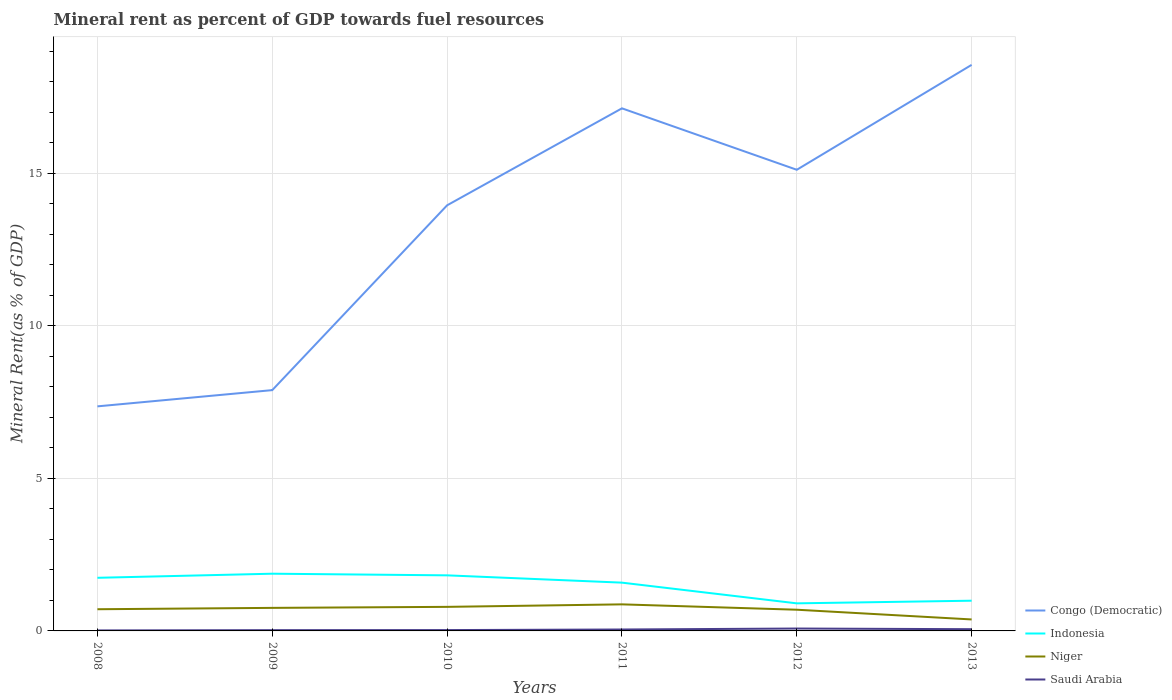How many different coloured lines are there?
Provide a short and direct response. 4. Across all years, what is the maximum mineral rent in Indonesia?
Offer a terse response. 0.9. In which year was the mineral rent in Niger maximum?
Your answer should be compact. 2013. What is the total mineral rent in Saudi Arabia in the graph?
Offer a very short reply. -0.01. What is the difference between the highest and the second highest mineral rent in Indonesia?
Provide a short and direct response. 0.97. How many lines are there?
Your response must be concise. 4. How many years are there in the graph?
Ensure brevity in your answer.  6. Are the values on the major ticks of Y-axis written in scientific E-notation?
Offer a very short reply. No. Does the graph contain grids?
Ensure brevity in your answer.  Yes. Where does the legend appear in the graph?
Provide a succinct answer. Bottom right. What is the title of the graph?
Give a very brief answer. Mineral rent as percent of GDP towards fuel resources. Does "Dominica" appear as one of the legend labels in the graph?
Make the answer very short. No. What is the label or title of the Y-axis?
Give a very brief answer. Mineral Rent(as % of GDP). What is the Mineral Rent(as % of GDP) in Congo (Democratic) in 2008?
Offer a terse response. 7.36. What is the Mineral Rent(as % of GDP) of Indonesia in 2008?
Your answer should be compact. 1.74. What is the Mineral Rent(as % of GDP) in Niger in 2008?
Your answer should be compact. 0.71. What is the Mineral Rent(as % of GDP) in Saudi Arabia in 2008?
Your response must be concise. 0.02. What is the Mineral Rent(as % of GDP) in Congo (Democratic) in 2009?
Ensure brevity in your answer.  7.89. What is the Mineral Rent(as % of GDP) of Indonesia in 2009?
Make the answer very short. 1.87. What is the Mineral Rent(as % of GDP) of Niger in 2009?
Give a very brief answer. 0.76. What is the Mineral Rent(as % of GDP) of Saudi Arabia in 2009?
Give a very brief answer. 0.03. What is the Mineral Rent(as % of GDP) in Congo (Democratic) in 2010?
Offer a very short reply. 13.95. What is the Mineral Rent(as % of GDP) in Indonesia in 2010?
Keep it short and to the point. 1.82. What is the Mineral Rent(as % of GDP) in Niger in 2010?
Your answer should be compact. 0.79. What is the Mineral Rent(as % of GDP) in Saudi Arabia in 2010?
Give a very brief answer. 0.03. What is the Mineral Rent(as % of GDP) in Congo (Democratic) in 2011?
Provide a short and direct response. 17.13. What is the Mineral Rent(as % of GDP) in Indonesia in 2011?
Make the answer very short. 1.58. What is the Mineral Rent(as % of GDP) in Niger in 2011?
Provide a succinct answer. 0.87. What is the Mineral Rent(as % of GDP) of Saudi Arabia in 2011?
Offer a terse response. 0.05. What is the Mineral Rent(as % of GDP) in Congo (Democratic) in 2012?
Offer a terse response. 15.11. What is the Mineral Rent(as % of GDP) of Indonesia in 2012?
Give a very brief answer. 0.9. What is the Mineral Rent(as % of GDP) in Niger in 2012?
Provide a succinct answer. 0.69. What is the Mineral Rent(as % of GDP) in Saudi Arabia in 2012?
Your answer should be very brief. 0.08. What is the Mineral Rent(as % of GDP) in Congo (Democratic) in 2013?
Ensure brevity in your answer.  18.55. What is the Mineral Rent(as % of GDP) in Indonesia in 2013?
Offer a very short reply. 0.99. What is the Mineral Rent(as % of GDP) in Niger in 2013?
Provide a short and direct response. 0.38. What is the Mineral Rent(as % of GDP) in Saudi Arabia in 2013?
Provide a short and direct response. 0.06. Across all years, what is the maximum Mineral Rent(as % of GDP) of Congo (Democratic)?
Your answer should be compact. 18.55. Across all years, what is the maximum Mineral Rent(as % of GDP) of Indonesia?
Offer a very short reply. 1.87. Across all years, what is the maximum Mineral Rent(as % of GDP) in Niger?
Your answer should be compact. 0.87. Across all years, what is the maximum Mineral Rent(as % of GDP) of Saudi Arabia?
Provide a short and direct response. 0.08. Across all years, what is the minimum Mineral Rent(as % of GDP) in Congo (Democratic)?
Give a very brief answer. 7.36. Across all years, what is the minimum Mineral Rent(as % of GDP) of Indonesia?
Provide a succinct answer. 0.9. Across all years, what is the minimum Mineral Rent(as % of GDP) of Niger?
Offer a very short reply. 0.38. Across all years, what is the minimum Mineral Rent(as % of GDP) in Saudi Arabia?
Your answer should be very brief. 0.02. What is the total Mineral Rent(as % of GDP) in Congo (Democratic) in the graph?
Keep it short and to the point. 79.99. What is the total Mineral Rent(as % of GDP) of Indonesia in the graph?
Give a very brief answer. 8.91. What is the total Mineral Rent(as % of GDP) of Niger in the graph?
Keep it short and to the point. 4.2. What is the total Mineral Rent(as % of GDP) of Saudi Arabia in the graph?
Give a very brief answer. 0.25. What is the difference between the Mineral Rent(as % of GDP) of Congo (Democratic) in 2008 and that in 2009?
Make the answer very short. -0.53. What is the difference between the Mineral Rent(as % of GDP) of Indonesia in 2008 and that in 2009?
Offer a very short reply. -0.13. What is the difference between the Mineral Rent(as % of GDP) in Niger in 2008 and that in 2009?
Your answer should be very brief. -0.04. What is the difference between the Mineral Rent(as % of GDP) in Saudi Arabia in 2008 and that in 2009?
Offer a terse response. -0.01. What is the difference between the Mineral Rent(as % of GDP) in Congo (Democratic) in 2008 and that in 2010?
Ensure brevity in your answer.  -6.59. What is the difference between the Mineral Rent(as % of GDP) in Indonesia in 2008 and that in 2010?
Offer a very short reply. -0.08. What is the difference between the Mineral Rent(as % of GDP) in Niger in 2008 and that in 2010?
Your answer should be very brief. -0.08. What is the difference between the Mineral Rent(as % of GDP) of Saudi Arabia in 2008 and that in 2010?
Keep it short and to the point. -0.01. What is the difference between the Mineral Rent(as % of GDP) in Congo (Democratic) in 2008 and that in 2011?
Keep it short and to the point. -9.77. What is the difference between the Mineral Rent(as % of GDP) of Indonesia in 2008 and that in 2011?
Your answer should be very brief. 0.16. What is the difference between the Mineral Rent(as % of GDP) in Niger in 2008 and that in 2011?
Keep it short and to the point. -0.16. What is the difference between the Mineral Rent(as % of GDP) in Saudi Arabia in 2008 and that in 2011?
Provide a short and direct response. -0.03. What is the difference between the Mineral Rent(as % of GDP) of Congo (Democratic) in 2008 and that in 2012?
Your answer should be compact. -7.75. What is the difference between the Mineral Rent(as % of GDP) in Indonesia in 2008 and that in 2012?
Your answer should be compact. 0.84. What is the difference between the Mineral Rent(as % of GDP) in Niger in 2008 and that in 2012?
Your answer should be compact. 0.02. What is the difference between the Mineral Rent(as % of GDP) of Saudi Arabia in 2008 and that in 2012?
Offer a terse response. -0.06. What is the difference between the Mineral Rent(as % of GDP) of Congo (Democratic) in 2008 and that in 2013?
Your answer should be very brief. -11.19. What is the difference between the Mineral Rent(as % of GDP) of Indonesia in 2008 and that in 2013?
Make the answer very short. 0.75. What is the difference between the Mineral Rent(as % of GDP) of Niger in 2008 and that in 2013?
Provide a succinct answer. 0.33. What is the difference between the Mineral Rent(as % of GDP) of Saudi Arabia in 2008 and that in 2013?
Your answer should be compact. -0.04. What is the difference between the Mineral Rent(as % of GDP) of Congo (Democratic) in 2009 and that in 2010?
Your response must be concise. -6.06. What is the difference between the Mineral Rent(as % of GDP) of Indonesia in 2009 and that in 2010?
Provide a succinct answer. 0.05. What is the difference between the Mineral Rent(as % of GDP) in Niger in 2009 and that in 2010?
Your response must be concise. -0.03. What is the difference between the Mineral Rent(as % of GDP) of Saudi Arabia in 2009 and that in 2010?
Give a very brief answer. -0. What is the difference between the Mineral Rent(as % of GDP) of Congo (Democratic) in 2009 and that in 2011?
Offer a terse response. -9.24. What is the difference between the Mineral Rent(as % of GDP) in Indonesia in 2009 and that in 2011?
Your response must be concise. 0.29. What is the difference between the Mineral Rent(as % of GDP) in Niger in 2009 and that in 2011?
Make the answer very short. -0.11. What is the difference between the Mineral Rent(as % of GDP) in Saudi Arabia in 2009 and that in 2011?
Provide a short and direct response. -0.02. What is the difference between the Mineral Rent(as % of GDP) in Congo (Democratic) in 2009 and that in 2012?
Give a very brief answer. -7.22. What is the difference between the Mineral Rent(as % of GDP) in Indonesia in 2009 and that in 2012?
Your answer should be compact. 0.97. What is the difference between the Mineral Rent(as % of GDP) of Niger in 2009 and that in 2012?
Keep it short and to the point. 0.06. What is the difference between the Mineral Rent(as % of GDP) of Saudi Arabia in 2009 and that in 2012?
Provide a short and direct response. -0.05. What is the difference between the Mineral Rent(as % of GDP) in Congo (Democratic) in 2009 and that in 2013?
Your answer should be compact. -10.66. What is the difference between the Mineral Rent(as % of GDP) of Indonesia in 2009 and that in 2013?
Offer a terse response. 0.88. What is the difference between the Mineral Rent(as % of GDP) of Niger in 2009 and that in 2013?
Offer a very short reply. 0.38. What is the difference between the Mineral Rent(as % of GDP) in Saudi Arabia in 2009 and that in 2013?
Provide a short and direct response. -0.03. What is the difference between the Mineral Rent(as % of GDP) in Congo (Democratic) in 2010 and that in 2011?
Provide a succinct answer. -3.18. What is the difference between the Mineral Rent(as % of GDP) of Indonesia in 2010 and that in 2011?
Ensure brevity in your answer.  0.24. What is the difference between the Mineral Rent(as % of GDP) of Niger in 2010 and that in 2011?
Your response must be concise. -0.08. What is the difference between the Mineral Rent(as % of GDP) in Saudi Arabia in 2010 and that in 2011?
Your answer should be compact. -0.02. What is the difference between the Mineral Rent(as % of GDP) of Congo (Democratic) in 2010 and that in 2012?
Your answer should be very brief. -1.16. What is the difference between the Mineral Rent(as % of GDP) of Indonesia in 2010 and that in 2012?
Offer a terse response. 0.92. What is the difference between the Mineral Rent(as % of GDP) in Niger in 2010 and that in 2012?
Your response must be concise. 0.09. What is the difference between the Mineral Rent(as % of GDP) of Saudi Arabia in 2010 and that in 2012?
Give a very brief answer. -0.05. What is the difference between the Mineral Rent(as % of GDP) of Congo (Democratic) in 2010 and that in 2013?
Make the answer very short. -4.6. What is the difference between the Mineral Rent(as % of GDP) in Indonesia in 2010 and that in 2013?
Your answer should be very brief. 0.83. What is the difference between the Mineral Rent(as % of GDP) in Niger in 2010 and that in 2013?
Ensure brevity in your answer.  0.41. What is the difference between the Mineral Rent(as % of GDP) in Saudi Arabia in 2010 and that in 2013?
Provide a succinct answer. -0.03. What is the difference between the Mineral Rent(as % of GDP) of Congo (Democratic) in 2011 and that in 2012?
Offer a very short reply. 2.01. What is the difference between the Mineral Rent(as % of GDP) in Indonesia in 2011 and that in 2012?
Keep it short and to the point. 0.68. What is the difference between the Mineral Rent(as % of GDP) in Niger in 2011 and that in 2012?
Provide a short and direct response. 0.18. What is the difference between the Mineral Rent(as % of GDP) of Saudi Arabia in 2011 and that in 2012?
Keep it short and to the point. -0.03. What is the difference between the Mineral Rent(as % of GDP) of Congo (Democratic) in 2011 and that in 2013?
Offer a terse response. -1.42. What is the difference between the Mineral Rent(as % of GDP) in Indonesia in 2011 and that in 2013?
Make the answer very short. 0.59. What is the difference between the Mineral Rent(as % of GDP) of Niger in 2011 and that in 2013?
Provide a succinct answer. 0.49. What is the difference between the Mineral Rent(as % of GDP) in Saudi Arabia in 2011 and that in 2013?
Provide a short and direct response. -0.01. What is the difference between the Mineral Rent(as % of GDP) in Congo (Democratic) in 2012 and that in 2013?
Offer a terse response. -3.44. What is the difference between the Mineral Rent(as % of GDP) in Indonesia in 2012 and that in 2013?
Ensure brevity in your answer.  -0.09. What is the difference between the Mineral Rent(as % of GDP) of Niger in 2012 and that in 2013?
Offer a very short reply. 0.32. What is the difference between the Mineral Rent(as % of GDP) in Saudi Arabia in 2012 and that in 2013?
Your response must be concise. 0.02. What is the difference between the Mineral Rent(as % of GDP) of Congo (Democratic) in 2008 and the Mineral Rent(as % of GDP) of Indonesia in 2009?
Give a very brief answer. 5.48. What is the difference between the Mineral Rent(as % of GDP) in Congo (Democratic) in 2008 and the Mineral Rent(as % of GDP) in Niger in 2009?
Keep it short and to the point. 6.6. What is the difference between the Mineral Rent(as % of GDP) in Congo (Democratic) in 2008 and the Mineral Rent(as % of GDP) in Saudi Arabia in 2009?
Keep it short and to the point. 7.33. What is the difference between the Mineral Rent(as % of GDP) in Indonesia in 2008 and the Mineral Rent(as % of GDP) in Niger in 2009?
Offer a terse response. 0.99. What is the difference between the Mineral Rent(as % of GDP) of Indonesia in 2008 and the Mineral Rent(as % of GDP) of Saudi Arabia in 2009?
Keep it short and to the point. 1.72. What is the difference between the Mineral Rent(as % of GDP) in Niger in 2008 and the Mineral Rent(as % of GDP) in Saudi Arabia in 2009?
Keep it short and to the point. 0.69. What is the difference between the Mineral Rent(as % of GDP) of Congo (Democratic) in 2008 and the Mineral Rent(as % of GDP) of Indonesia in 2010?
Make the answer very short. 5.54. What is the difference between the Mineral Rent(as % of GDP) of Congo (Democratic) in 2008 and the Mineral Rent(as % of GDP) of Niger in 2010?
Your answer should be very brief. 6.57. What is the difference between the Mineral Rent(as % of GDP) of Congo (Democratic) in 2008 and the Mineral Rent(as % of GDP) of Saudi Arabia in 2010?
Your answer should be compact. 7.33. What is the difference between the Mineral Rent(as % of GDP) in Indonesia in 2008 and the Mineral Rent(as % of GDP) in Niger in 2010?
Provide a succinct answer. 0.95. What is the difference between the Mineral Rent(as % of GDP) in Indonesia in 2008 and the Mineral Rent(as % of GDP) in Saudi Arabia in 2010?
Your response must be concise. 1.71. What is the difference between the Mineral Rent(as % of GDP) of Niger in 2008 and the Mineral Rent(as % of GDP) of Saudi Arabia in 2010?
Give a very brief answer. 0.68. What is the difference between the Mineral Rent(as % of GDP) of Congo (Democratic) in 2008 and the Mineral Rent(as % of GDP) of Indonesia in 2011?
Your response must be concise. 5.78. What is the difference between the Mineral Rent(as % of GDP) of Congo (Democratic) in 2008 and the Mineral Rent(as % of GDP) of Niger in 2011?
Provide a short and direct response. 6.49. What is the difference between the Mineral Rent(as % of GDP) of Congo (Democratic) in 2008 and the Mineral Rent(as % of GDP) of Saudi Arabia in 2011?
Offer a terse response. 7.31. What is the difference between the Mineral Rent(as % of GDP) of Indonesia in 2008 and the Mineral Rent(as % of GDP) of Niger in 2011?
Give a very brief answer. 0.87. What is the difference between the Mineral Rent(as % of GDP) of Indonesia in 2008 and the Mineral Rent(as % of GDP) of Saudi Arabia in 2011?
Keep it short and to the point. 1.69. What is the difference between the Mineral Rent(as % of GDP) in Niger in 2008 and the Mineral Rent(as % of GDP) in Saudi Arabia in 2011?
Provide a succinct answer. 0.66. What is the difference between the Mineral Rent(as % of GDP) in Congo (Democratic) in 2008 and the Mineral Rent(as % of GDP) in Indonesia in 2012?
Ensure brevity in your answer.  6.46. What is the difference between the Mineral Rent(as % of GDP) of Congo (Democratic) in 2008 and the Mineral Rent(as % of GDP) of Niger in 2012?
Your answer should be compact. 6.66. What is the difference between the Mineral Rent(as % of GDP) in Congo (Democratic) in 2008 and the Mineral Rent(as % of GDP) in Saudi Arabia in 2012?
Provide a short and direct response. 7.28. What is the difference between the Mineral Rent(as % of GDP) in Indonesia in 2008 and the Mineral Rent(as % of GDP) in Niger in 2012?
Your answer should be compact. 1.05. What is the difference between the Mineral Rent(as % of GDP) of Indonesia in 2008 and the Mineral Rent(as % of GDP) of Saudi Arabia in 2012?
Ensure brevity in your answer.  1.66. What is the difference between the Mineral Rent(as % of GDP) in Niger in 2008 and the Mineral Rent(as % of GDP) in Saudi Arabia in 2012?
Your answer should be compact. 0.63. What is the difference between the Mineral Rent(as % of GDP) of Congo (Democratic) in 2008 and the Mineral Rent(as % of GDP) of Indonesia in 2013?
Ensure brevity in your answer.  6.37. What is the difference between the Mineral Rent(as % of GDP) of Congo (Democratic) in 2008 and the Mineral Rent(as % of GDP) of Niger in 2013?
Make the answer very short. 6.98. What is the difference between the Mineral Rent(as % of GDP) of Congo (Democratic) in 2008 and the Mineral Rent(as % of GDP) of Saudi Arabia in 2013?
Make the answer very short. 7.3. What is the difference between the Mineral Rent(as % of GDP) in Indonesia in 2008 and the Mineral Rent(as % of GDP) in Niger in 2013?
Ensure brevity in your answer.  1.36. What is the difference between the Mineral Rent(as % of GDP) of Indonesia in 2008 and the Mineral Rent(as % of GDP) of Saudi Arabia in 2013?
Your answer should be compact. 1.68. What is the difference between the Mineral Rent(as % of GDP) in Niger in 2008 and the Mineral Rent(as % of GDP) in Saudi Arabia in 2013?
Your answer should be compact. 0.65. What is the difference between the Mineral Rent(as % of GDP) in Congo (Democratic) in 2009 and the Mineral Rent(as % of GDP) in Indonesia in 2010?
Make the answer very short. 6.07. What is the difference between the Mineral Rent(as % of GDP) in Congo (Democratic) in 2009 and the Mineral Rent(as % of GDP) in Niger in 2010?
Offer a very short reply. 7.1. What is the difference between the Mineral Rent(as % of GDP) of Congo (Democratic) in 2009 and the Mineral Rent(as % of GDP) of Saudi Arabia in 2010?
Make the answer very short. 7.86. What is the difference between the Mineral Rent(as % of GDP) of Indonesia in 2009 and the Mineral Rent(as % of GDP) of Niger in 2010?
Provide a short and direct response. 1.09. What is the difference between the Mineral Rent(as % of GDP) of Indonesia in 2009 and the Mineral Rent(as % of GDP) of Saudi Arabia in 2010?
Keep it short and to the point. 1.85. What is the difference between the Mineral Rent(as % of GDP) of Niger in 2009 and the Mineral Rent(as % of GDP) of Saudi Arabia in 2010?
Give a very brief answer. 0.73. What is the difference between the Mineral Rent(as % of GDP) in Congo (Democratic) in 2009 and the Mineral Rent(as % of GDP) in Indonesia in 2011?
Offer a terse response. 6.31. What is the difference between the Mineral Rent(as % of GDP) in Congo (Democratic) in 2009 and the Mineral Rent(as % of GDP) in Niger in 2011?
Provide a short and direct response. 7.02. What is the difference between the Mineral Rent(as % of GDP) of Congo (Democratic) in 2009 and the Mineral Rent(as % of GDP) of Saudi Arabia in 2011?
Provide a succinct answer. 7.85. What is the difference between the Mineral Rent(as % of GDP) of Indonesia in 2009 and the Mineral Rent(as % of GDP) of Niger in 2011?
Give a very brief answer. 1. What is the difference between the Mineral Rent(as % of GDP) of Indonesia in 2009 and the Mineral Rent(as % of GDP) of Saudi Arabia in 2011?
Provide a short and direct response. 1.83. What is the difference between the Mineral Rent(as % of GDP) in Niger in 2009 and the Mineral Rent(as % of GDP) in Saudi Arabia in 2011?
Your answer should be compact. 0.71. What is the difference between the Mineral Rent(as % of GDP) in Congo (Democratic) in 2009 and the Mineral Rent(as % of GDP) in Indonesia in 2012?
Your answer should be compact. 6.99. What is the difference between the Mineral Rent(as % of GDP) in Congo (Democratic) in 2009 and the Mineral Rent(as % of GDP) in Niger in 2012?
Offer a terse response. 7.2. What is the difference between the Mineral Rent(as % of GDP) in Congo (Democratic) in 2009 and the Mineral Rent(as % of GDP) in Saudi Arabia in 2012?
Offer a terse response. 7.81. What is the difference between the Mineral Rent(as % of GDP) of Indonesia in 2009 and the Mineral Rent(as % of GDP) of Niger in 2012?
Your response must be concise. 1.18. What is the difference between the Mineral Rent(as % of GDP) of Indonesia in 2009 and the Mineral Rent(as % of GDP) of Saudi Arabia in 2012?
Your response must be concise. 1.8. What is the difference between the Mineral Rent(as % of GDP) of Niger in 2009 and the Mineral Rent(as % of GDP) of Saudi Arabia in 2012?
Your answer should be very brief. 0.68. What is the difference between the Mineral Rent(as % of GDP) of Congo (Democratic) in 2009 and the Mineral Rent(as % of GDP) of Indonesia in 2013?
Provide a succinct answer. 6.9. What is the difference between the Mineral Rent(as % of GDP) in Congo (Democratic) in 2009 and the Mineral Rent(as % of GDP) in Niger in 2013?
Give a very brief answer. 7.52. What is the difference between the Mineral Rent(as % of GDP) in Congo (Democratic) in 2009 and the Mineral Rent(as % of GDP) in Saudi Arabia in 2013?
Provide a short and direct response. 7.83. What is the difference between the Mineral Rent(as % of GDP) of Indonesia in 2009 and the Mineral Rent(as % of GDP) of Niger in 2013?
Provide a short and direct response. 1.5. What is the difference between the Mineral Rent(as % of GDP) of Indonesia in 2009 and the Mineral Rent(as % of GDP) of Saudi Arabia in 2013?
Your response must be concise. 1.82. What is the difference between the Mineral Rent(as % of GDP) of Niger in 2009 and the Mineral Rent(as % of GDP) of Saudi Arabia in 2013?
Your response must be concise. 0.7. What is the difference between the Mineral Rent(as % of GDP) of Congo (Democratic) in 2010 and the Mineral Rent(as % of GDP) of Indonesia in 2011?
Your answer should be very brief. 12.37. What is the difference between the Mineral Rent(as % of GDP) in Congo (Democratic) in 2010 and the Mineral Rent(as % of GDP) in Niger in 2011?
Provide a short and direct response. 13.08. What is the difference between the Mineral Rent(as % of GDP) of Congo (Democratic) in 2010 and the Mineral Rent(as % of GDP) of Saudi Arabia in 2011?
Give a very brief answer. 13.9. What is the difference between the Mineral Rent(as % of GDP) of Indonesia in 2010 and the Mineral Rent(as % of GDP) of Niger in 2011?
Provide a short and direct response. 0.95. What is the difference between the Mineral Rent(as % of GDP) of Indonesia in 2010 and the Mineral Rent(as % of GDP) of Saudi Arabia in 2011?
Provide a short and direct response. 1.77. What is the difference between the Mineral Rent(as % of GDP) of Niger in 2010 and the Mineral Rent(as % of GDP) of Saudi Arabia in 2011?
Ensure brevity in your answer.  0.74. What is the difference between the Mineral Rent(as % of GDP) in Congo (Democratic) in 2010 and the Mineral Rent(as % of GDP) in Indonesia in 2012?
Your answer should be very brief. 13.04. What is the difference between the Mineral Rent(as % of GDP) in Congo (Democratic) in 2010 and the Mineral Rent(as % of GDP) in Niger in 2012?
Your answer should be very brief. 13.25. What is the difference between the Mineral Rent(as % of GDP) of Congo (Democratic) in 2010 and the Mineral Rent(as % of GDP) of Saudi Arabia in 2012?
Provide a succinct answer. 13.87. What is the difference between the Mineral Rent(as % of GDP) in Indonesia in 2010 and the Mineral Rent(as % of GDP) in Niger in 2012?
Offer a very short reply. 1.13. What is the difference between the Mineral Rent(as % of GDP) in Indonesia in 2010 and the Mineral Rent(as % of GDP) in Saudi Arabia in 2012?
Offer a terse response. 1.74. What is the difference between the Mineral Rent(as % of GDP) of Niger in 2010 and the Mineral Rent(as % of GDP) of Saudi Arabia in 2012?
Your answer should be very brief. 0.71. What is the difference between the Mineral Rent(as % of GDP) in Congo (Democratic) in 2010 and the Mineral Rent(as % of GDP) in Indonesia in 2013?
Keep it short and to the point. 12.96. What is the difference between the Mineral Rent(as % of GDP) in Congo (Democratic) in 2010 and the Mineral Rent(as % of GDP) in Niger in 2013?
Offer a very short reply. 13.57. What is the difference between the Mineral Rent(as % of GDP) in Congo (Democratic) in 2010 and the Mineral Rent(as % of GDP) in Saudi Arabia in 2013?
Provide a short and direct response. 13.89. What is the difference between the Mineral Rent(as % of GDP) in Indonesia in 2010 and the Mineral Rent(as % of GDP) in Niger in 2013?
Keep it short and to the point. 1.45. What is the difference between the Mineral Rent(as % of GDP) of Indonesia in 2010 and the Mineral Rent(as % of GDP) of Saudi Arabia in 2013?
Give a very brief answer. 1.76. What is the difference between the Mineral Rent(as % of GDP) in Niger in 2010 and the Mineral Rent(as % of GDP) in Saudi Arabia in 2013?
Offer a very short reply. 0.73. What is the difference between the Mineral Rent(as % of GDP) in Congo (Democratic) in 2011 and the Mineral Rent(as % of GDP) in Indonesia in 2012?
Offer a terse response. 16.22. What is the difference between the Mineral Rent(as % of GDP) of Congo (Democratic) in 2011 and the Mineral Rent(as % of GDP) of Niger in 2012?
Keep it short and to the point. 16.43. What is the difference between the Mineral Rent(as % of GDP) of Congo (Democratic) in 2011 and the Mineral Rent(as % of GDP) of Saudi Arabia in 2012?
Offer a terse response. 17.05. What is the difference between the Mineral Rent(as % of GDP) in Indonesia in 2011 and the Mineral Rent(as % of GDP) in Niger in 2012?
Offer a very short reply. 0.89. What is the difference between the Mineral Rent(as % of GDP) in Indonesia in 2011 and the Mineral Rent(as % of GDP) in Saudi Arabia in 2012?
Provide a succinct answer. 1.5. What is the difference between the Mineral Rent(as % of GDP) in Niger in 2011 and the Mineral Rent(as % of GDP) in Saudi Arabia in 2012?
Offer a very short reply. 0.79. What is the difference between the Mineral Rent(as % of GDP) of Congo (Democratic) in 2011 and the Mineral Rent(as % of GDP) of Indonesia in 2013?
Your answer should be compact. 16.14. What is the difference between the Mineral Rent(as % of GDP) of Congo (Democratic) in 2011 and the Mineral Rent(as % of GDP) of Niger in 2013?
Your response must be concise. 16.75. What is the difference between the Mineral Rent(as % of GDP) of Congo (Democratic) in 2011 and the Mineral Rent(as % of GDP) of Saudi Arabia in 2013?
Provide a succinct answer. 17.07. What is the difference between the Mineral Rent(as % of GDP) of Indonesia in 2011 and the Mineral Rent(as % of GDP) of Niger in 2013?
Provide a succinct answer. 1.21. What is the difference between the Mineral Rent(as % of GDP) in Indonesia in 2011 and the Mineral Rent(as % of GDP) in Saudi Arabia in 2013?
Make the answer very short. 1.53. What is the difference between the Mineral Rent(as % of GDP) in Niger in 2011 and the Mineral Rent(as % of GDP) in Saudi Arabia in 2013?
Give a very brief answer. 0.81. What is the difference between the Mineral Rent(as % of GDP) in Congo (Democratic) in 2012 and the Mineral Rent(as % of GDP) in Indonesia in 2013?
Keep it short and to the point. 14.12. What is the difference between the Mineral Rent(as % of GDP) of Congo (Democratic) in 2012 and the Mineral Rent(as % of GDP) of Niger in 2013?
Your response must be concise. 14.74. What is the difference between the Mineral Rent(as % of GDP) in Congo (Democratic) in 2012 and the Mineral Rent(as % of GDP) in Saudi Arabia in 2013?
Your answer should be compact. 15.06. What is the difference between the Mineral Rent(as % of GDP) in Indonesia in 2012 and the Mineral Rent(as % of GDP) in Niger in 2013?
Offer a terse response. 0.53. What is the difference between the Mineral Rent(as % of GDP) in Indonesia in 2012 and the Mineral Rent(as % of GDP) in Saudi Arabia in 2013?
Give a very brief answer. 0.85. What is the difference between the Mineral Rent(as % of GDP) in Niger in 2012 and the Mineral Rent(as % of GDP) in Saudi Arabia in 2013?
Offer a terse response. 0.64. What is the average Mineral Rent(as % of GDP) in Congo (Democratic) per year?
Provide a succinct answer. 13.33. What is the average Mineral Rent(as % of GDP) in Indonesia per year?
Make the answer very short. 1.49. What is the average Mineral Rent(as % of GDP) of Niger per year?
Make the answer very short. 0.7. What is the average Mineral Rent(as % of GDP) of Saudi Arabia per year?
Give a very brief answer. 0.04. In the year 2008, what is the difference between the Mineral Rent(as % of GDP) in Congo (Democratic) and Mineral Rent(as % of GDP) in Indonesia?
Provide a short and direct response. 5.62. In the year 2008, what is the difference between the Mineral Rent(as % of GDP) in Congo (Democratic) and Mineral Rent(as % of GDP) in Niger?
Your answer should be very brief. 6.65. In the year 2008, what is the difference between the Mineral Rent(as % of GDP) in Congo (Democratic) and Mineral Rent(as % of GDP) in Saudi Arabia?
Give a very brief answer. 7.34. In the year 2008, what is the difference between the Mineral Rent(as % of GDP) in Indonesia and Mineral Rent(as % of GDP) in Niger?
Your answer should be compact. 1.03. In the year 2008, what is the difference between the Mineral Rent(as % of GDP) of Indonesia and Mineral Rent(as % of GDP) of Saudi Arabia?
Your answer should be compact. 1.72. In the year 2008, what is the difference between the Mineral Rent(as % of GDP) of Niger and Mineral Rent(as % of GDP) of Saudi Arabia?
Provide a short and direct response. 0.69. In the year 2009, what is the difference between the Mineral Rent(as % of GDP) of Congo (Democratic) and Mineral Rent(as % of GDP) of Indonesia?
Keep it short and to the point. 6.02. In the year 2009, what is the difference between the Mineral Rent(as % of GDP) of Congo (Democratic) and Mineral Rent(as % of GDP) of Niger?
Offer a terse response. 7.14. In the year 2009, what is the difference between the Mineral Rent(as % of GDP) in Congo (Democratic) and Mineral Rent(as % of GDP) in Saudi Arabia?
Your answer should be very brief. 7.87. In the year 2009, what is the difference between the Mineral Rent(as % of GDP) in Indonesia and Mineral Rent(as % of GDP) in Niger?
Provide a succinct answer. 1.12. In the year 2009, what is the difference between the Mineral Rent(as % of GDP) of Indonesia and Mineral Rent(as % of GDP) of Saudi Arabia?
Offer a very short reply. 1.85. In the year 2009, what is the difference between the Mineral Rent(as % of GDP) in Niger and Mineral Rent(as % of GDP) in Saudi Arabia?
Provide a succinct answer. 0.73. In the year 2010, what is the difference between the Mineral Rent(as % of GDP) in Congo (Democratic) and Mineral Rent(as % of GDP) in Indonesia?
Give a very brief answer. 12.13. In the year 2010, what is the difference between the Mineral Rent(as % of GDP) in Congo (Democratic) and Mineral Rent(as % of GDP) in Niger?
Ensure brevity in your answer.  13.16. In the year 2010, what is the difference between the Mineral Rent(as % of GDP) in Congo (Democratic) and Mineral Rent(as % of GDP) in Saudi Arabia?
Make the answer very short. 13.92. In the year 2010, what is the difference between the Mineral Rent(as % of GDP) in Indonesia and Mineral Rent(as % of GDP) in Niger?
Keep it short and to the point. 1.03. In the year 2010, what is the difference between the Mineral Rent(as % of GDP) in Indonesia and Mineral Rent(as % of GDP) in Saudi Arabia?
Ensure brevity in your answer.  1.79. In the year 2010, what is the difference between the Mineral Rent(as % of GDP) in Niger and Mineral Rent(as % of GDP) in Saudi Arabia?
Ensure brevity in your answer.  0.76. In the year 2011, what is the difference between the Mineral Rent(as % of GDP) in Congo (Democratic) and Mineral Rent(as % of GDP) in Indonesia?
Provide a short and direct response. 15.54. In the year 2011, what is the difference between the Mineral Rent(as % of GDP) of Congo (Democratic) and Mineral Rent(as % of GDP) of Niger?
Keep it short and to the point. 16.26. In the year 2011, what is the difference between the Mineral Rent(as % of GDP) of Congo (Democratic) and Mineral Rent(as % of GDP) of Saudi Arabia?
Ensure brevity in your answer.  17.08. In the year 2011, what is the difference between the Mineral Rent(as % of GDP) of Indonesia and Mineral Rent(as % of GDP) of Niger?
Your response must be concise. 0.71. In the year 2011, what is the difference between the Mineral Rent(as % of GDP) in Indonesia and Mineral Rent(as % of GDP) in Saudi Arabia?
Offer a terse response. 1.54. In the year 2011, what is the difference between the Mineral Rent(as % of GDP) in Niger and Mineral Rent(as % of GDP) in Saudi Arabia?
Offer a very short reply. 0.82. In the year 2012, what is the difference between the Mineral Rent(as % of GDP) in Congo (Democratic) and Mineral Rent(as % of GDP) in Indonesia?
Your answer should be compact. 14.21. In the year 2012, what is the difference between the Mineral Rent(as % of GDP) of Congo (Democratic) and Mineral Rent(as % of GDP) of Niger?
Offer a very short reply. 14.42. In the year 2012, what is the difference between the Mineral Rent(as % of GDP) of Congo (Democratic) and Mineral Rent(as % of GDP) of Saudi Arabia?
Ensure brevity in your answer.  15.03. In the year 2012, what is the difference between the Mineral Rent(as % of GDP) in Indonesia and Mineral Rent(as % of GDP) in Niger?
Keep it short and to the point. 0.21. In the year 2012, what is the difference between the Mineral Rent(as % of GDP) in Indonesia and Mineral Rent(as % of GDP) in Saudi Arabia?
Provide a succinct answer. 0.83. In the year 2012, what is the difference between the Mineral Rent(as % of GDP) of Niger and Mineral Rent(as % of GDP) of Saudi Arabia?
Keep it short and to the point. 0.62. In the year 2013, what is the difference between the Mineral Rent(as % of GDP) in Congo (Democratic) and Mineral Rent(as % of GDP) in Indonesia?
Make the answer very short. 17.56. In the year 2013, what is the difference between the Mineral Rent(as % of GDP) of Congo (Democratic) and Mineral Rent(as % of GDP) of Niger?
Your answer should be compact. 18.18. In the year 2013, what is the difference between the Mineral Rent(as % of GDP) in Congo (Democratic) and Mineral Rent(as % of GDP) in Saudi Arabia?
Offer a terse response. 18.49. In the year 2013, what is the difference between the Mineral Rent(as % of GDP) of Indonesia and Mineral Rent(as % of GDP) of Niger?
Make the answer very short. 0.61. In the year 2013, what is the difference between the Mineral Rent(as % of GDP) of Indonesia and Mineral Rent(as % of GDP) of Saudi Arabia?
Ensure brevity in your answer.  0.93. In the year 2013, what is the difference between the Mineral Rent(as % of GDP) of Niger and Mineral Rent(as % of GDP) of Saudi Arabia?
Offer a very short reply. 0.32. What is the ratio of the Mineral Rent(as % of GDP) of Congo (Democratic) in 2008 to that in 2009?
Ensure brevity in your answer.  0.93. What is the ratio of the Mineral Rent(as % of GDP) in Indonesia in 2008 to that in 2009?
Give a very brief answer. 0.93. What is the ratio of the Mineral Rent(as % of GDP) of Niger in 2008 to that in 2009?
Ensure brevity in your answer.  0.94. What is the ratio of the Mineral Rent(as % of GDP) of Saudi Arabia in 2008 to that in 2009?
Give a very brief answer. 0.65. What is the ratio of the Mineral Rent(as % of GDP) in Congo (Democratic) in 2008 to that in 2010?
Offer a very short reply. 0.53. What is the ratio of the Mineral Rent(as % of GDP) of Indonesia in 2008 to that in 2010?
Provide a short and direct response. 0.96. What is the ratio of the Mineral Rent(as % of GDP) in Niger in 2008 to that in 2010?
Provide a short and direct response. 0.9. What is the ratio of the Mineral Rent(as % of GDP) of Saudi Arabia in 2008 to that in 2010?
Your answer should be very brief. 0.59. What is the ratio of the Mineral Rent(as % of GDP) in Congo (Democratic) in 2008 to that in 2011?
Give a very brief answer. 0.43. What is the ratio of the Mineral Rent(as % of GDP) of Indonesia in 2008 to that in 2011?
Provide a short and direct response. 1.1. What is the ratio of the Mineral Rent(as % of GDP) of Niger in 2008 to that in 2011?
Provide a short and direct response. 0.82. What is the ratio of the Mineral Rent(as % of GDP) in Saudi Arabia in 2008 to that in 2011?
Make the answer very short. 0.35. What is the ratio of the Mineral Rent(as % of GDP) in Congo (Democratic) in 2008 to that in 2012?
Offer a terse response. 0.49. What is the ratio of the Mineral Rent(as % of GDP) in Indonesia in 2008 to that in 2012?
Offer a terse response. 1.93. What is the ratio of the Mineral Rent(as % of GDP) in Niger in 2008 to that in 2012?
Provide a short and direct response. 1.02. What is the ratio of the Mineral Rent(as % of GDP) in Saudi Arabia in 2008 to that in 2012?
Provide a short and direct response. 0.21. What is the ratio of the Mineral Rent(as % of GDP) in Congo (Democratic) in 2008 to that in 2013?
Provide a short and direct response. 0.4. What is the ratio of the Mineral Rent(as % of GDP) in Indonesia in 2008 to that in 2013?
Provide a short and direct response. 1.76. What is the ratio of the Mineral Rent(as % of GDP) in Niger in 2008 to that in 2013?
Give a very brief answer. 1.89. What is the ratio of the Mineral Rent(as % of GDP) in Saudi Arabia in 2008 to that in 2013?
Offer a terse response. 0.29. What is the ratio of the Mineral Rent(as % of GDP) of Congo (Democratic) in 2009 to that in 2010?
Your answer should be very brief. 0.57. What is the ratio of the Mineral Rent(as % of GDP) of Indonesia in 2009 to that in 2010?
Offer a terse response. 1.03. What is the ratio of the Mineral Rent(as % of GDP) of Niger in 2009 to that in 2010?
Your response must be concise. 0.96. What is the ratio of the Mineral Rent(as % of GDP) in Saudi Arabia in 2009 to that in 2010?
Keep it short and to the point. 0.9. What is the ratio of the Mineral Rent(as % of GDP) of Congo (Democratic) in 2009 to that in 2011?
Your answer should be very brief. 0.46. What is the ratio of the Mineral Rent(as % of GDP) in Indonesia in 2009 to that in 2011?
Provide a succinct answer. 1.19. What is the ratio of the Mineral Rent(as % of GDP) of Niger in 2009 to that in 2011?
Make the answer very short. 0.87. What is the ratio of the Mineral Rent(as % of GDP) in Saudi Arabia in 2009 to that in 2011?
Your answer should be compact. 0.54. What is the ratio of the Mineral Rent(as % of GDP) in Congo (Democratic) in 2009 to that in 2012?
Make the answer very short. 0.52. What is the ratio of the Mineral Rent(as % of GDP) of Indonesia in 2009 to that in 2012?
Offer a very short reply. 2.07. What is the ratio of the Mineral Rent(as % of GDP) of Niger in 2009 to that in 2012?
Offer a very short reply. 1.09. What is the ratio of the Mineral Rent(as % of GDP) of Saudi Arabia in 2009 to that in 2012?
Provide a short and direct response. 0.32. What is the ratio of the Mineral Rent(as % of GDP) in Congo (Democratic) in 2009 to that in 2013?
Your answer should be very brief. 0.43. What is the ratio of the Mineral Rent(as % of GDP) of Indonesia in 2009 to that in 2013?
Offer a terse response. 1.89. What is the ratio of the Mineral Rent(as % of GDP) of Niger in 2009 to that in 2013?
Your response must be concise. 2.01. What is the ratio of the Mineral Rent(as % of GDP) of Saudi Arabia in 2009 to that in 2013?
Offer a very short reply. 0.44. What is the ratio of the Mineral Rent(as % of GDP) in Congo (Democratic) in 2010 to that in 2011?
Provide a succinct answer. 0.81. What is the ratio of the Mineral Rent(as % of GDP) in Indonesia in 2010 to that in 2011?
Your response must be concise. 1.15. What is the ratio of the Mineral Rent(as % of GDP) in Niger in 2010 to that in 2011?
Your answer should be very brief. 0.91. What is the ratio of the Mineral Rent(as % of GDP) in Saudi Arabia in 2010 to that in 2011?
Make the answer very short. 0.6. What is the ratio of the Mineral Rent(as % of GDP) of Congo (Democratic) in 2010 to that in 2012?
Your answer should be very brief. 0.92. What is the ratio of the Mineral Rent(as % of GDP) in Indonesia in 2010 to that in 2012?
Your answer should be very brief. 2.02. What is the ratio of the Mineral Rent(as % of GDP) in Niger in 2010 to that in 2012?
Provide a short and direct response. 1.13. What is the ratio of the Mineral Rent(as % of GDP) in Saudi Arabia in 2010 to that in 2012?
Keep it short and to the point. 0.36. What is the ratio of the Mineral Rent(as % of GDP) of Congo (Democratic) in 2010 to that in 2013?
Offer a terse response. 0.75. What is the ratio of the Mineral Rent(as % of GDP) of Indonesia in 2010 to that in 2013?
Ensure brevity in your answer.  1.84. What is the ratio of the Mineral Rent(as % of GDP) in Niger in 2010 to that in 2013?
Offer a very short reply. 2.1. What is the ratio of the Mineral Rent(as % of GDP) in Saudi Arabia in 2010 to that in 2013?
Your answer should be very brief. 0.49. What is the ratio of the Mineral Rent(as % of GDP) in Congo (Democratic) in 2011 to that in 2012?
Your answer should be very brief. 1.13. What is the ratio of the Mineral Rent(as % of GDP) of Indonesia in 2011 to that in 2012?
Your response must be concise. 1.75. What is the ratio of the Mineral Rent(as % of GDP) of Niger in 2011 to that in 2012?
Ensure brevity in your answer.  1.25. What is the ratio of the Mineral Rent(as % of GDP) in Saudi Arabia in 2011 to that in 2012?
Offer a very short reply. 0.59. What is the ratio of the Mineral Rent(as % of GDP) in Congo (Democratic) in 2011 to that in 2013?
Your answer should be compact. 0.92. What is the ratio of the Mineral Rent(as % of GDP) of Indonesia in 2011 to that in 2013?
Your answer should be very brief. 1.6. What is the ratio of the Mineral Rent(as % of GDP) of Niger in 2011 to that in 2013?
Offer a terse response. 2.31. What is the ratio of the Mineral Rent(as % of GDP) in Saudi Arabia in 2011 to that in 2013?
Provide a short and direct response. 0.81. What is the ratio of the Mineral Rent(as % of GDP) of Congo (Democratic) in 2012 to that in 2013?
Your answer should be very brief. 0.81. What is the ratio of the Mineral Rent(as % of GDP) in Indonesia in 2012 to that in 2013?
Offer a terse response. 0.91. What is the ratio of the Mineral Rent(as % of GDP) of Niger in 2012 to that in 2013?
Provide a succinct answer. 1.85. What is the ratio of the Mineral Rent(as % of GDP) of Saudi Arabia in 2012 to that in 2013?
Your response must be concise. 1.37. What is the difference between the highest and the second highest Mineral Rent(as % of GDP) of Congo (Democratic)?
Your response must be concise. 1.42. What is the difference between the highest and the second highest Mineral Rent(as % of GDP) in Indonesia?
Your answer should be very brief. 0.05. What is the difference between the highest and the second highest Mineral Rent(as % of GDP) in Niger?
Offer a terse response. 0.08. What is the difference between the highest and the second highest Mineral Rent(as % of GDP) in Saudi Arabia?
Your response must be concise. 0.02. What is the difference between the highest and the lowest Mineral Rent(as % of GDP) in Congo (Democratic)?
Your answer should be very brief. 11.19. What is the difference between the highest and the lowest Mineral Rent(as % of GDP) of Indonesia?
Keep it short and to the point. 0.97. What is the difference between the highest and the lowest Mineral Rent(as % of GDP) of Niger?
Ensure brevity in your answer.  0.49. What is the difference between the highest and the lowest Mineral Rent(as % of GDP) in Saudi Arabia?
Provide a succinct answer. 0.06. 